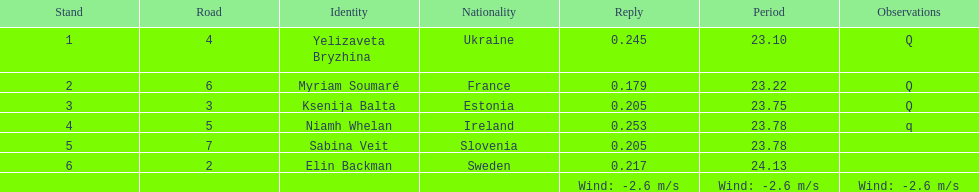Who is the female athlete that secured the top position in heat 1 of the women's 200 meters? Yelizaveta Bryzhina. 